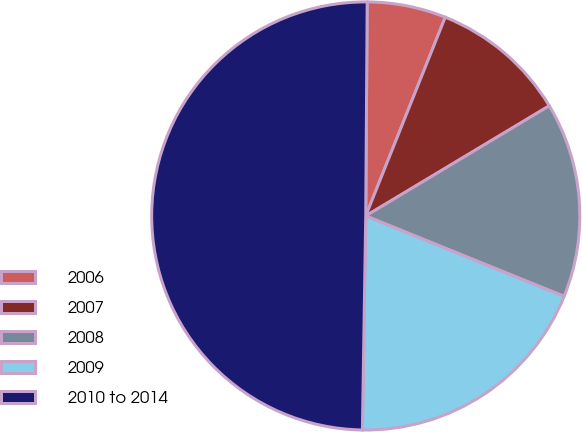Convert chart to OTSL. <chart><loc_0><loc_0><loc_500><loc_500><pie_chart><fcel>2006<fcel>2007<fcel>2008<fcel>2009<fcel>2010 to 2014<nl><fcel>5.95%<fcel>10.34%<fcel>14.73%<fcel>19.12%<fcel>49.86%<nl></chart> 